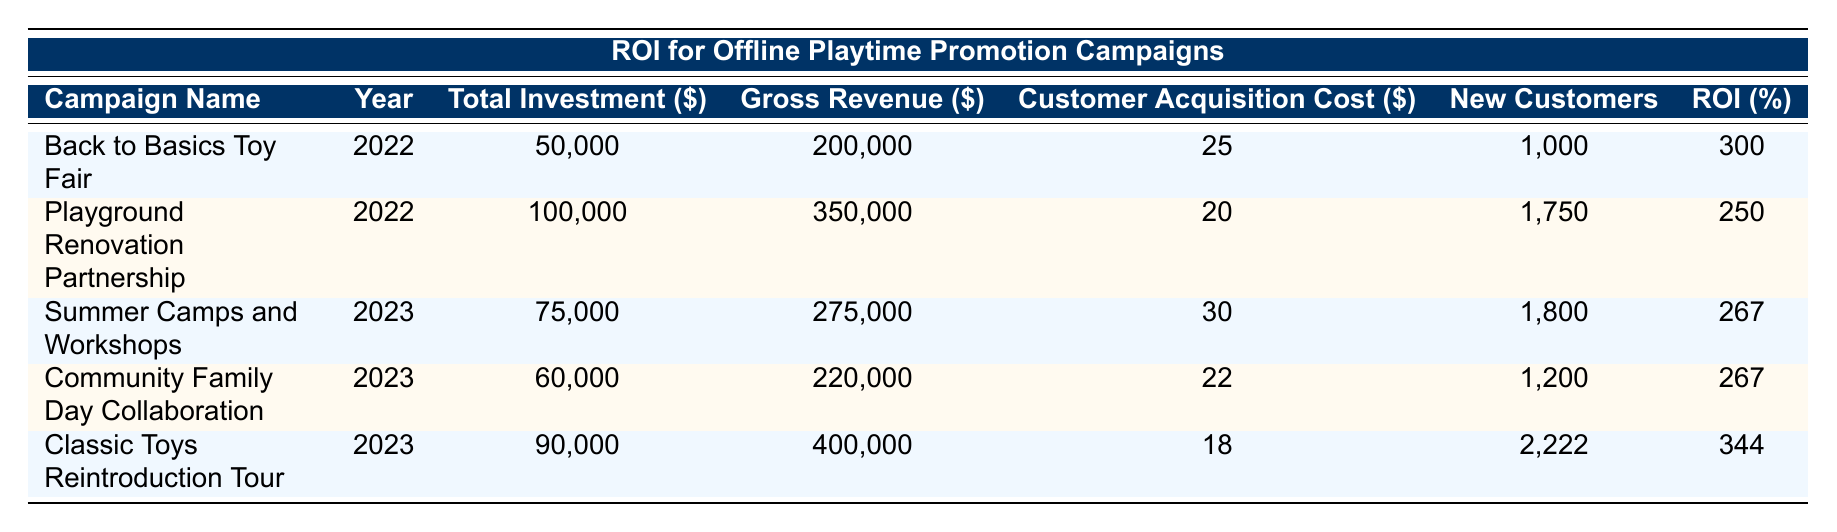What was the total investment for the "Classic Toys Reintroduction Tour"? The total investment amount can be found in the corresponding row for the "Classic Toys Reintroduction Tour" campaign, which is listed as 90,000.
Answer: 90,000 How many new customers were gained from the "Community Family Day Collaboration"? Looking at the row for the "Community Family Day Collaboration," the number of new customers gained is explicitly listed as 1,200.
Answer: 1,200 What is the total gross revenue generated from all campaigns in 2022? To find the total gross revenue for 2022, I will add the gross revenues of both campaigns from that year: 200,000 (Back to Basics Toy Fair) + 350,000 (Playground Renovation Partnership) = 550,000.
Answer: 550,000 Is the customer acquisition cost for the "Summer Camps and Workshops" lower than that for the "Back to Basics Toy Fair"? The customer acquisition cost for "Summer Camps and Workshops" is 30, while for "Back to Basics Toy Fair," it is 25. Therefore, since 30 is greater than 25, the answer is false.
Answer: No What is the average ROI percentage for the campaigns conducted in 2023? To find the average ROI for 2023, I first sum the ROI percentages: 267 (Summer Camps and Workshops) + 267 (Community Family Day Collaboration) + 344 (Classic Toys Reintroduction Tour) = 878. There are three campaigns, so I divide 878 by 3 to get an average of approximately 292.67.
Answer: 292.67 Which campaign had the highest ROI percentage and what was that percentage? By reviewing the ROI percentage of all campaigns, "Classic Toys Reintroduction Tour" had the highest ROI at 344 percent.
Answer: Classic Toys Reintroduction Tour, 344 How much revenue was generated from merchandise during the "Back to Basics Toy Fair"? The breakdown for the "Back to Basics Toy Fair" lists revenue from merchandise as 20,000, which is explicitly stated in the data.
Answer: 20,000 Which campaign had the lowest customer acquisition cost? The customer acquisition costs for each campaign are: 25 (Back to Basics Toy Fair), 20 (Playground Renovation Partnership), 30 (Summer Camps and Workshops), 22 (Community Family Day Collaboration), and 18 (Classic Toys Reintroduction Tour). The lowest is 18 for the "Classic Toys Reintroduction Tour."
Answer: Classic Toys Reintroduction Tour 